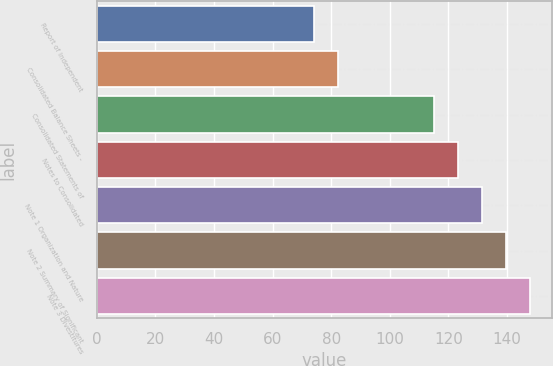Convert chart. <chart><loc_0><loc_0><loc_500><loc_500><bar_chart><fcel>Report of Independent<fcel>Consolidated Balance Sheets -<fcel>Consolidated Statements of<fcel>Notes to Consolidated<fcel>Note 1 Organization and Nature<fcel>Note 2 Summary of Significant<fcel>Note 3 Divestitures<nl><fcel>74<fcel>82.2<fcel>115<fcel>123.2<fcel>131.4<fcel>139.6<fcel>147.8<nl></chart> 